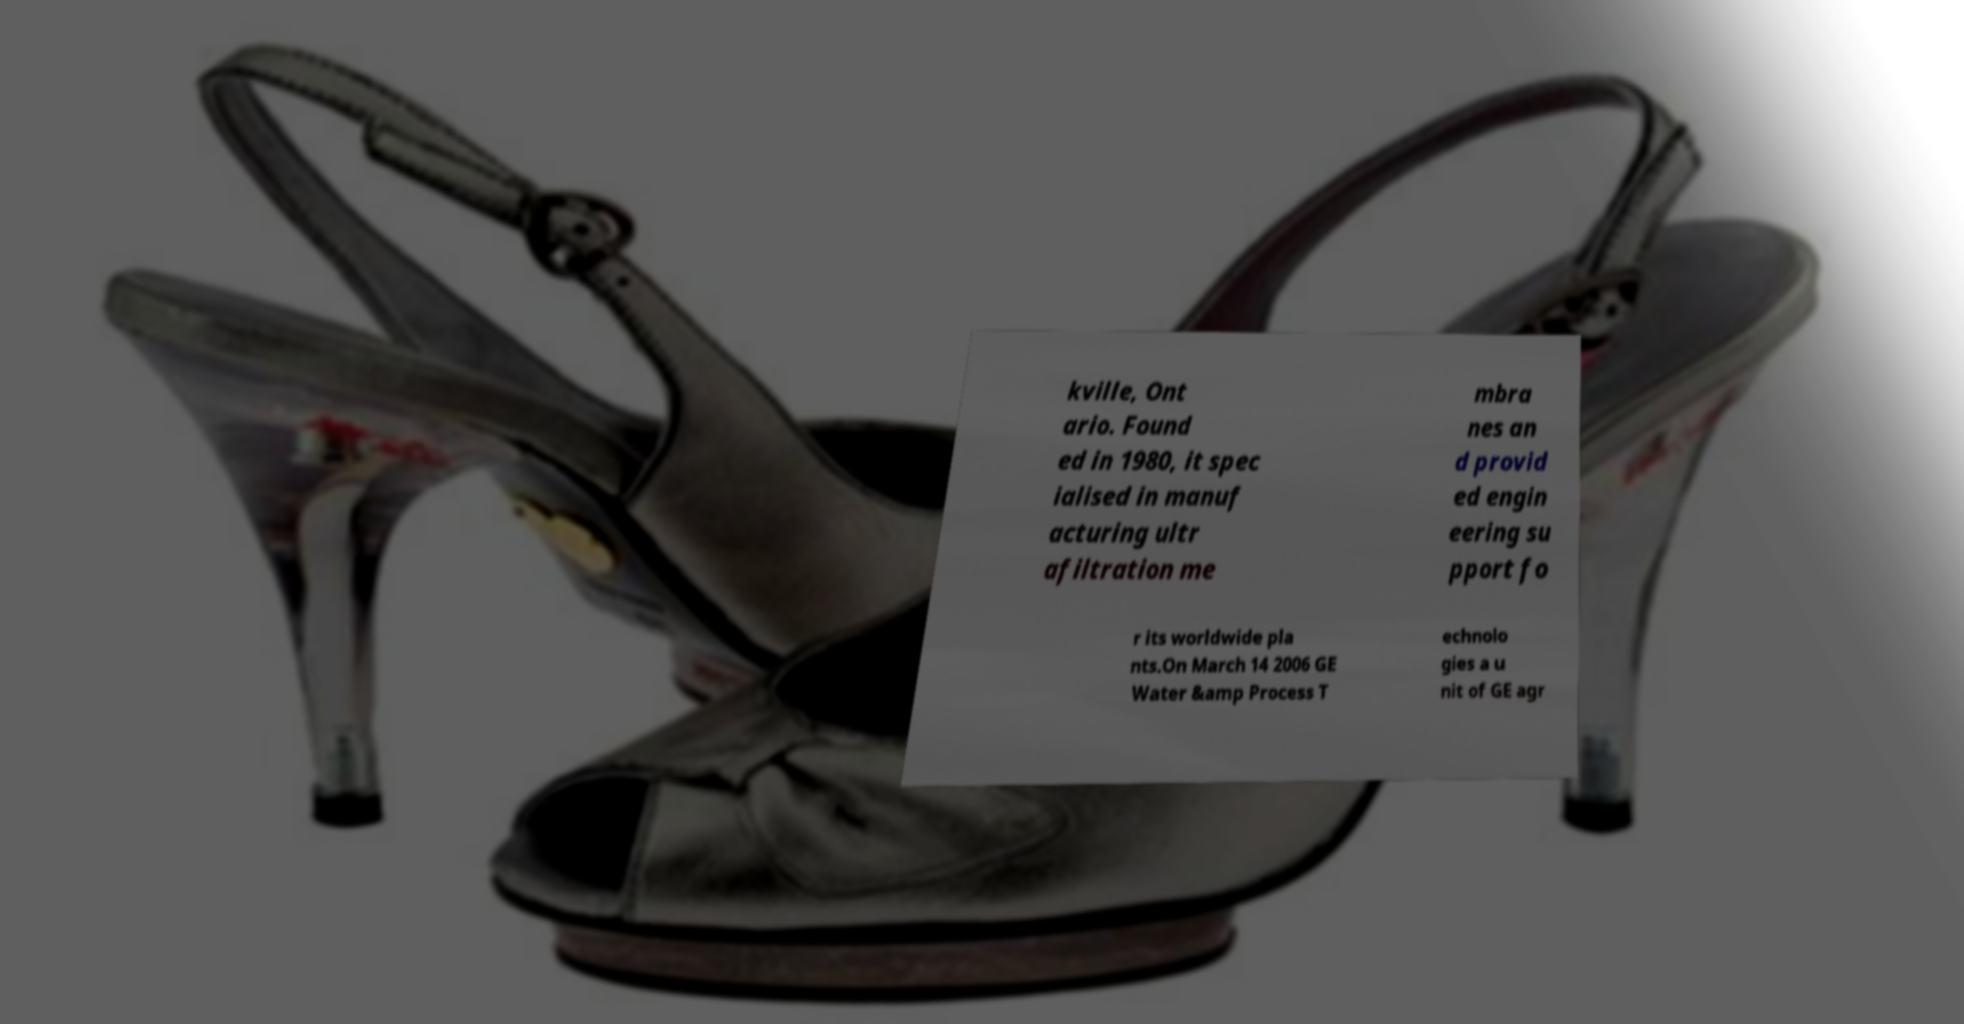Please identify and transcribe the text found in this image. kville, Ont ario. Found ed in 1980, it spec ialised in manuf acturing ultr afiltration me mbra nes an d provid ed engin eering su pport fo r its worldwide pla nts.On March 14 2006 GE Water &amp Process T echnolo gies a u nit of GE agr 